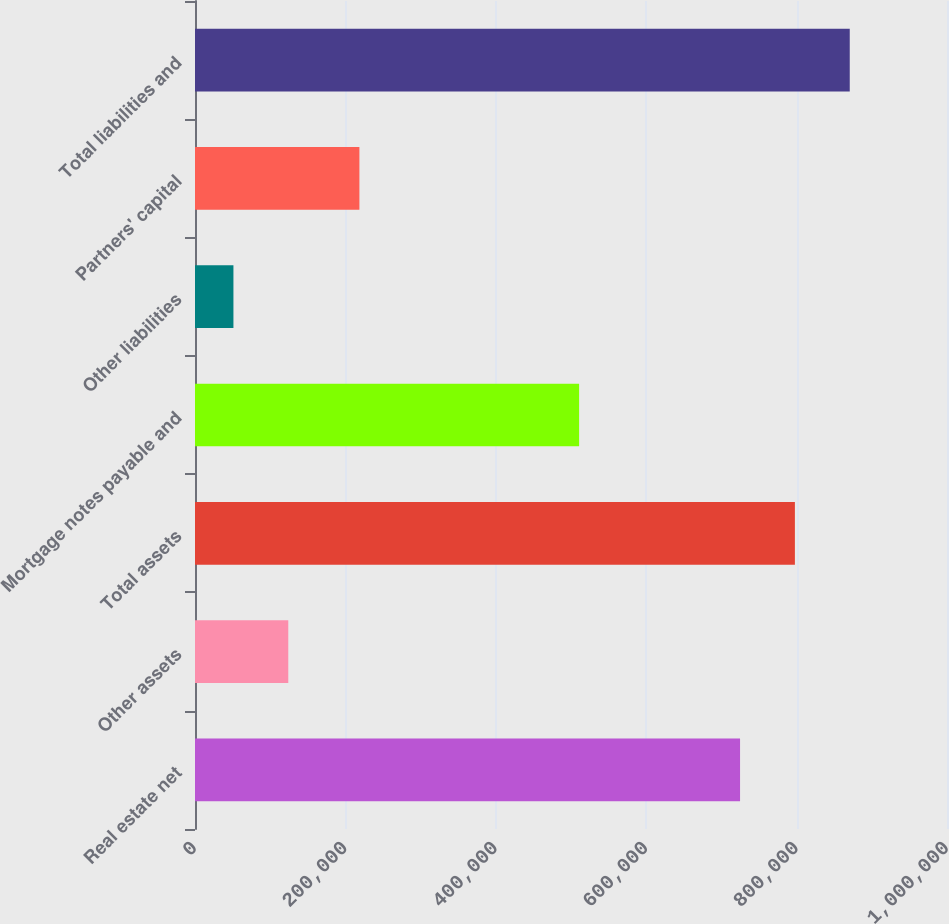<chart> <loc_0><loc_0><loc_500><loc_500><bar_chart><fcel>Real estate net<fcel>Other assets<fcel>Total assets<fcel>Mortgage notes payable and<fcel>Other liabilities<fcel>Partners' capital<fcel>Total liabilities and<nl><fcel>724795<fcel>124048<fcel>797735<fcel>510784<fcel>51108<fcel>218619<fcel>870676<nl></chart> 